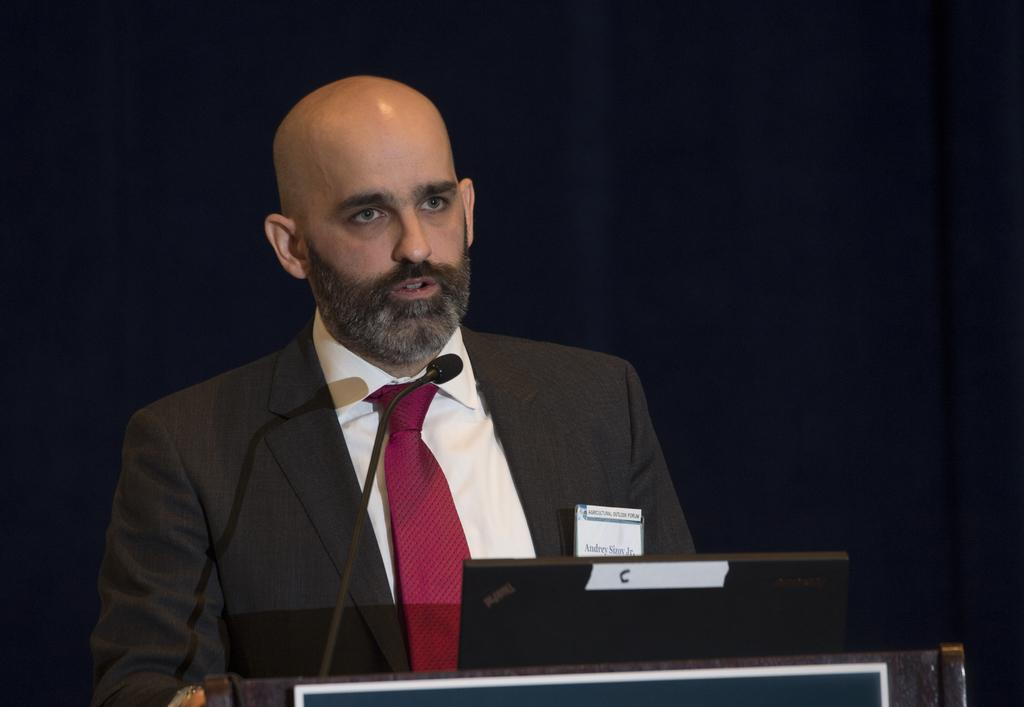Who or what is present in the image? There is a person in the image. What object is the person using? There is a microphone in the image, which the person might be using. What other item can be seen in the image? There is a device in the image. What is on the object in the image? There is a board on an object in the image. What can be seen behind the person and objects? The background is visible in the image. What word is written on the heart in the image? There is no heart or word present in the image. 